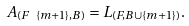Convert formula to latex. <formula><loc_0><loc_0><loc_500><loc_500>A _ { ( F \ \{ m + 1 \} , B ) } = L _ { ( F , B \cup \{ m + 1 \} ) } .</formula> 